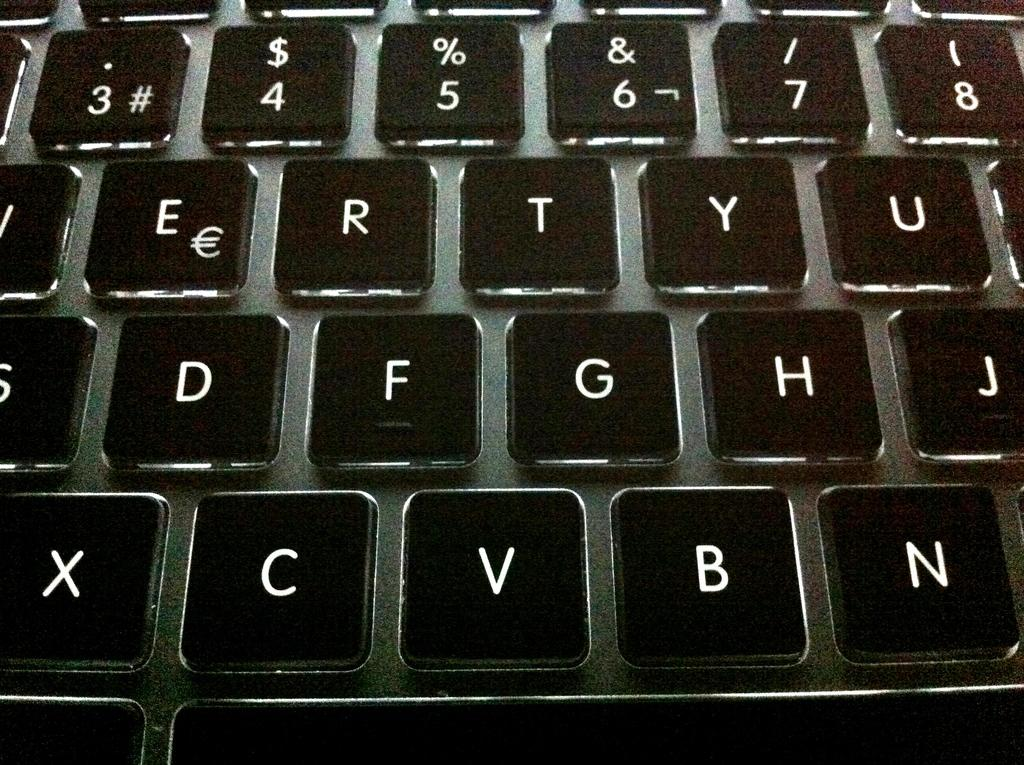Provide a one-sentence caption for the provided image. Black and white keyboard with letters and numbers. 